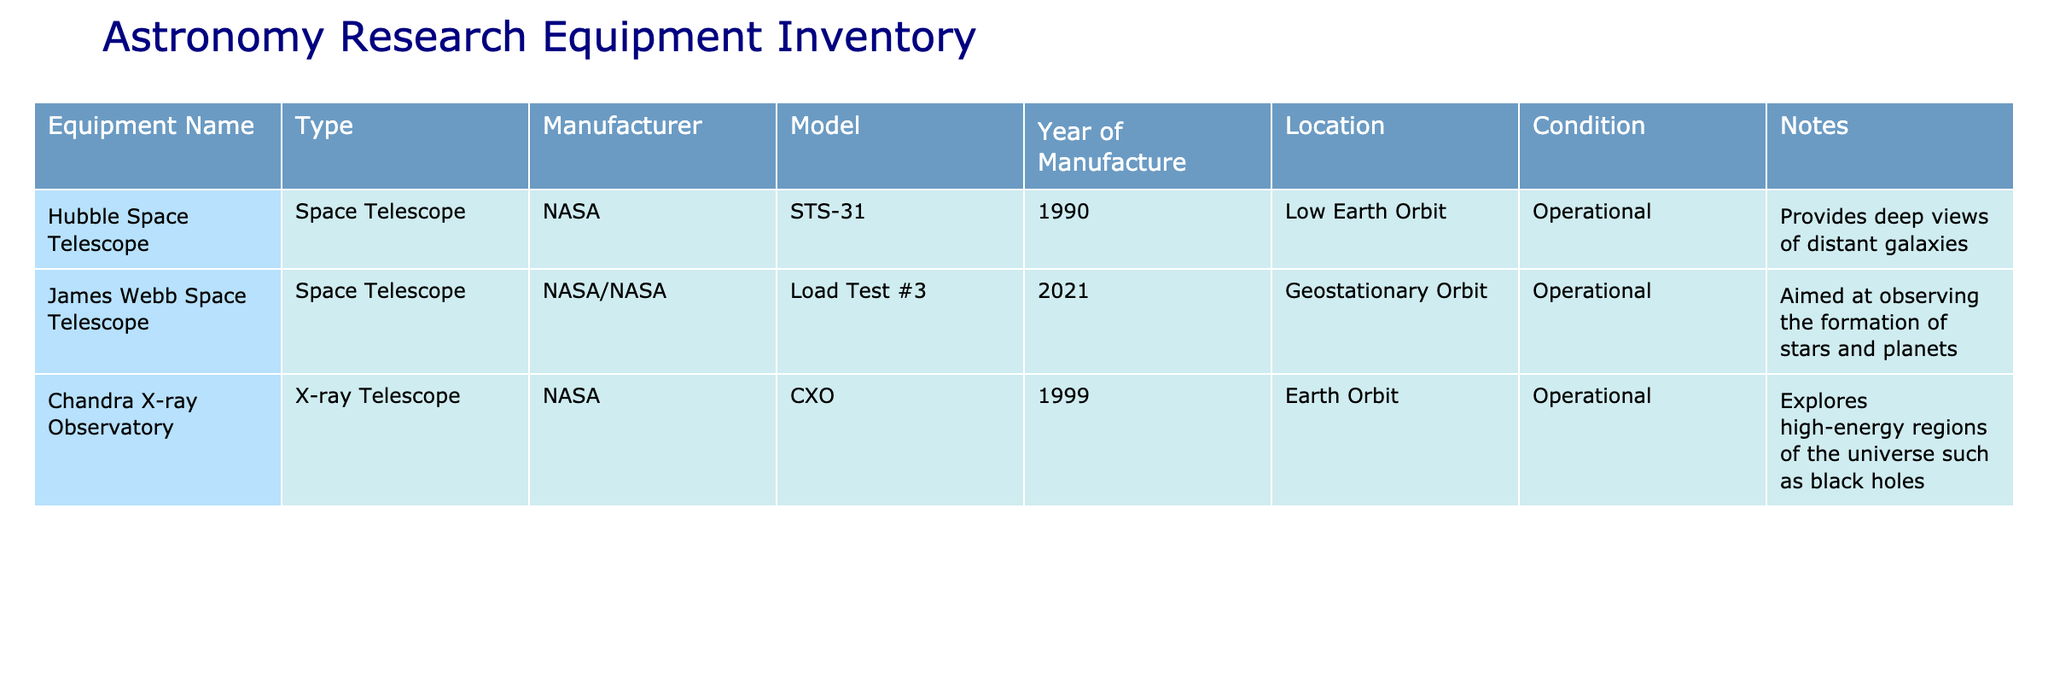What is the equipment name of the telescope launched in 2021? Referring to the table, the equipment launched in 2021 is the "James Webb Space Telescope."
Answer: James Webb Space Telescope Which equipment is located in Low Earth Orbit? The table shows that the "Hubble Space Telescope" is located in Low Earth Orbit.
Answer: Hubble Space Telescope True or False: The Chandra X-ray Observatory is operational. The table states that the condition of the Chandra X-ray Observatory is "Operational," making the statement true.
Answer: True What is the difference in years of manufacture between the Hubble Space Telescope and the James Webb Space Telescope? The Hubble Space Telescope was manufactured in 1990 and the James Webb Space Telescope in 2021. The difference is 2021 - 1990 = 31 years.
Answer: 31 years Which manufacturer produces both the Hubble Space Telescope and the James Webb Space Telescope? The table shows that both telescopes are manufactured by NASA; thus, they share the same manufacturer.
Answer: NASA What is the average year of manufacture for the equipment listed? Adding the years of manufacture (1990 + 2021 + 1999 = 6010) and dividing by the total number of equipment (3) gives 6010 / 3 = 2003.3. The average is approximately 2003.
Answer: 2003.3 True or False: All equipment listed provides observations of distant galaxies. The table indicates that the Hubble Space Telescope and James Webb Space Telescope provide observations related to galaxies, but not the Chandra X-ray Observatory, which focuses on high-energy regions. Therefore, the statement is false.
Answer: False What is the equipment type of the Chandra X-ray Observatory? Looking at the table, the equipment type for the Chandra X-ray Observatory is listed as "X-ray Telescope."
Answer: X-ray Telescope Which equipment focuses on exploring black holes? According to the notes in the table, the Chandra X-ray Observatory explores high-energy regions of the universe such as black holes, making it the answer.
Answer: Chandra X-ray Observatory 